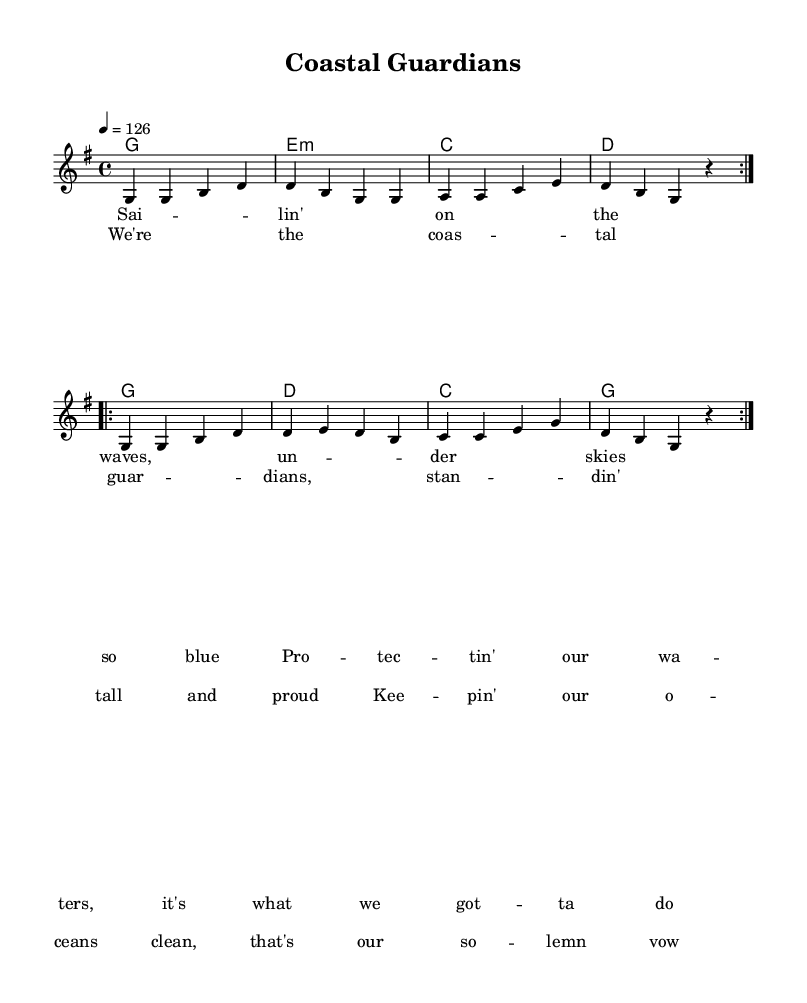What is the key signature of this music? The key signature is G major, which has one sharp (F#). This is determined by looking at the key signature placed at the beginning of the staff.
Answer: G major What is the time signature of this piece? The time signature is 4/4, indicated at the start of the score. This means there are four beats in each measure, and the quarter note gets one beat.
Answer: 4/4 What is the tempo marking of the piece? The tempo marking is 126 beats per minute, noted at the beginning of the score with the instruction "4 = 126". This indicates the pace at which the piece should be played.
Answer: 126 How many times is the verse repeated? The verse is repeated twice, indicated by the "repeat volta 2" markings before the melody section for the verses. This notation tells the performer to play the section two times before continuing.
Answer: 2 What is the starting note of the melody? The starting note of the melody is G. This can be observed at the beginning of the melody staff, where the note G is the first note played.
Answer: G What is the lyrical theme of the chorus? The theme of the chorus praises coastal guardianship and ocean conservation, focusing on standing tall and keeping oceans clean. The lyrics convey a sense of pride and commitment to protecting coastal waters.
Answer: Coastal guardianship 